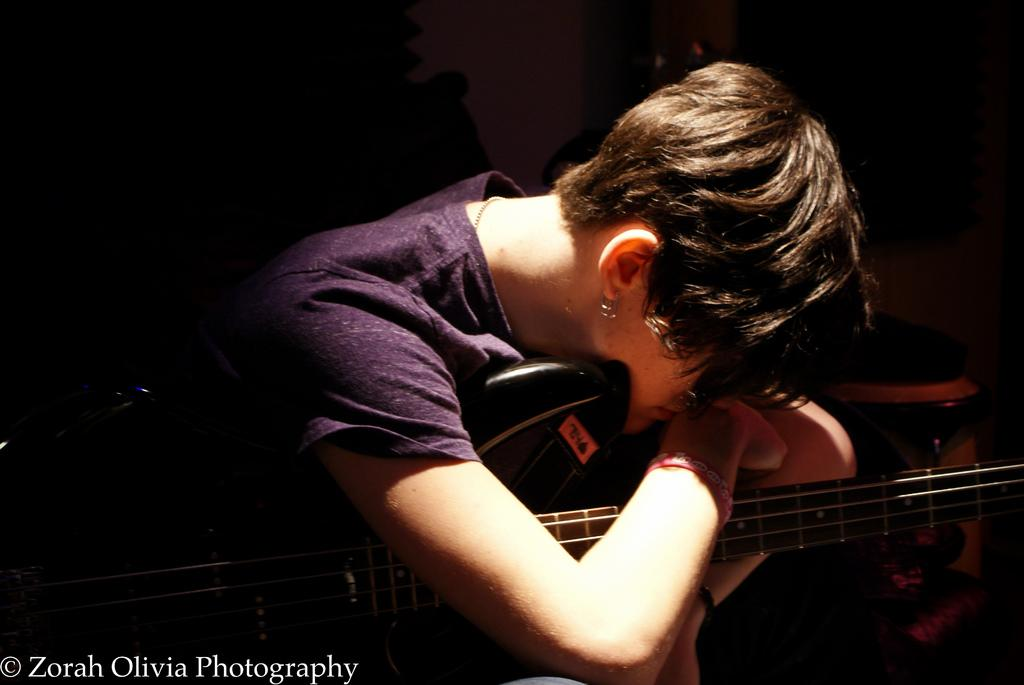Who is the main subject in the image? There is a woman in the image. What is the woman doing in the image? The woman is sitting in the image. What object is the woman holding in the image? The woman is holding a guitar in the image. What type of government is depicted in the image? There is no depiction of a government in the image; it features a woman sitting and holding a guitar. How many rabbits can be seen in the image? There are no rabbits present in the image. 